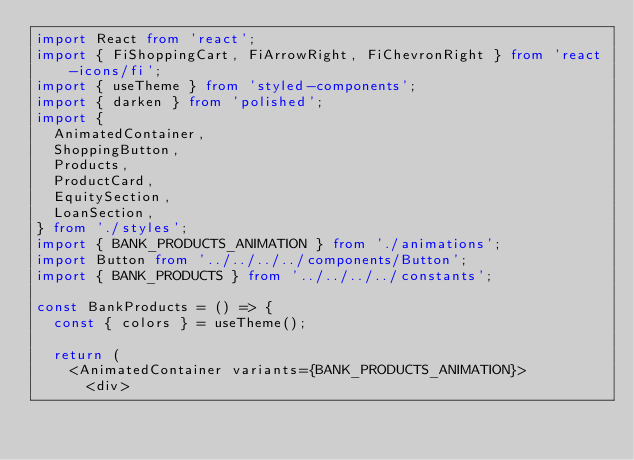Convert code to text. <code><loc_0><loc_0><loc_500><loc_500><_TypeScript_>import React from 'react';
import { FiShoppingCart, FiArrowRight, FiChevronRight } from 'react-icons/fi';
import { useTheme } from 'styled-components';
import { darken } from 'polished';
import {
  AnimatedContainer,
  ShoppingButton,
  Products,
  ProductCard,
  EquitySection,
  LoanSection,
} from './styles';
import { BANK_PRODUCTS_ANIMATION } from './animations';
import Button from '../../../../components/Button';
import { BANK_PRODUCTS } from '../../../../constants';

const BankProducts = () => {
  const { colors } = useTheme();

  return (
    <AnimatedContainer variants={BANK_PRODUCTS_ANIMATION}>
      <div></code> 